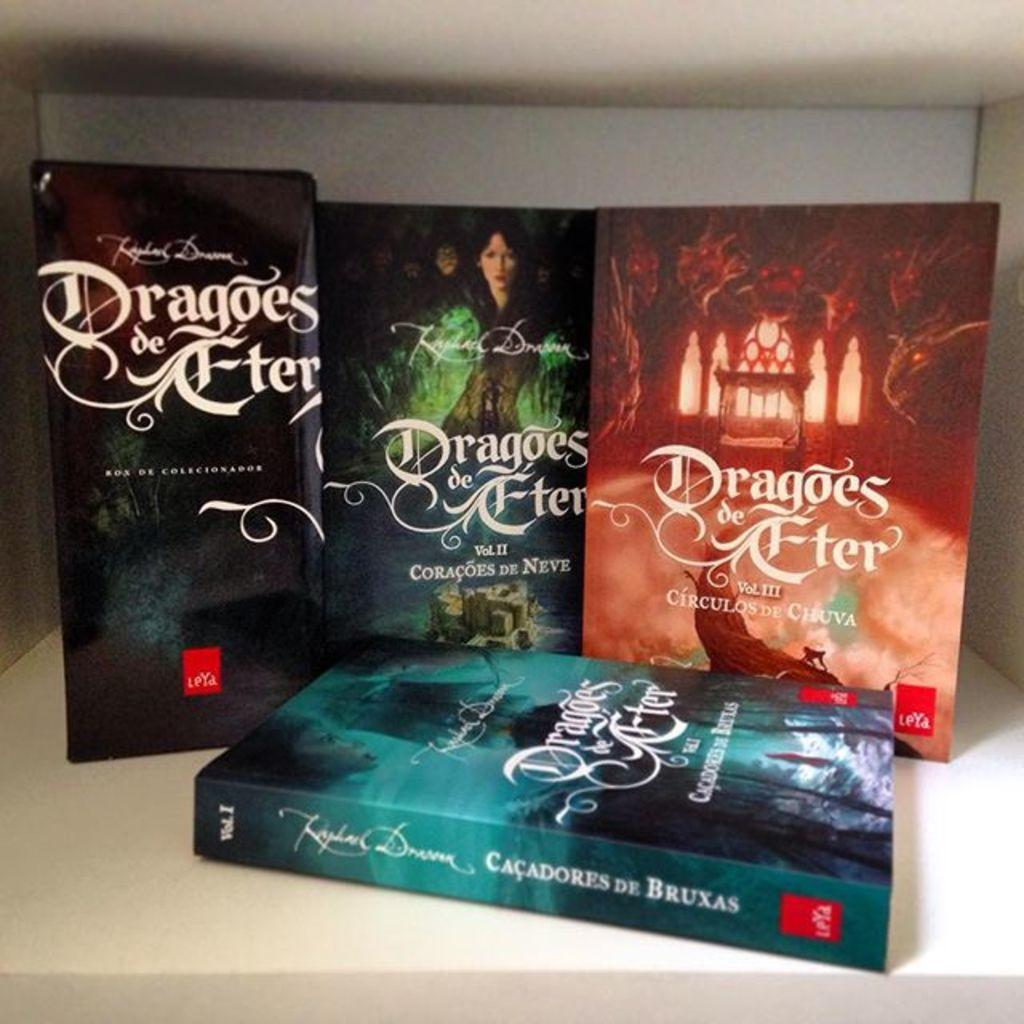<image>
Present a compact description of the photo's key features. Books from a series are shown with volume II and III and two others present. 